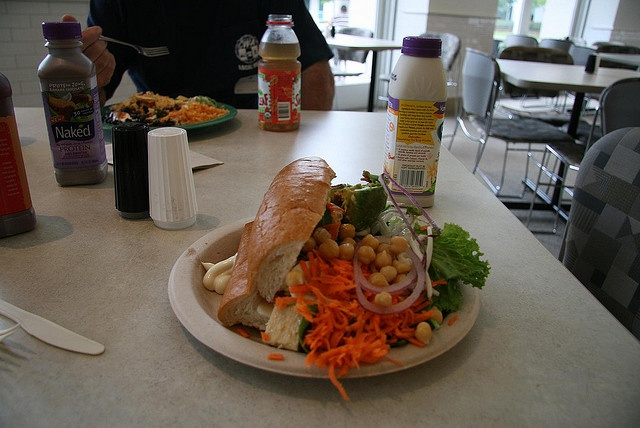Describe the objects in this image and their specific colors. I can see dining table in black, gray, and darkgray tones, sandwich in black, maroon, and brown tones, people in black, maroon, and gray tones, chair in black, gray, and purple tones, and carrot in black, maroon, and brown tones in this image. 